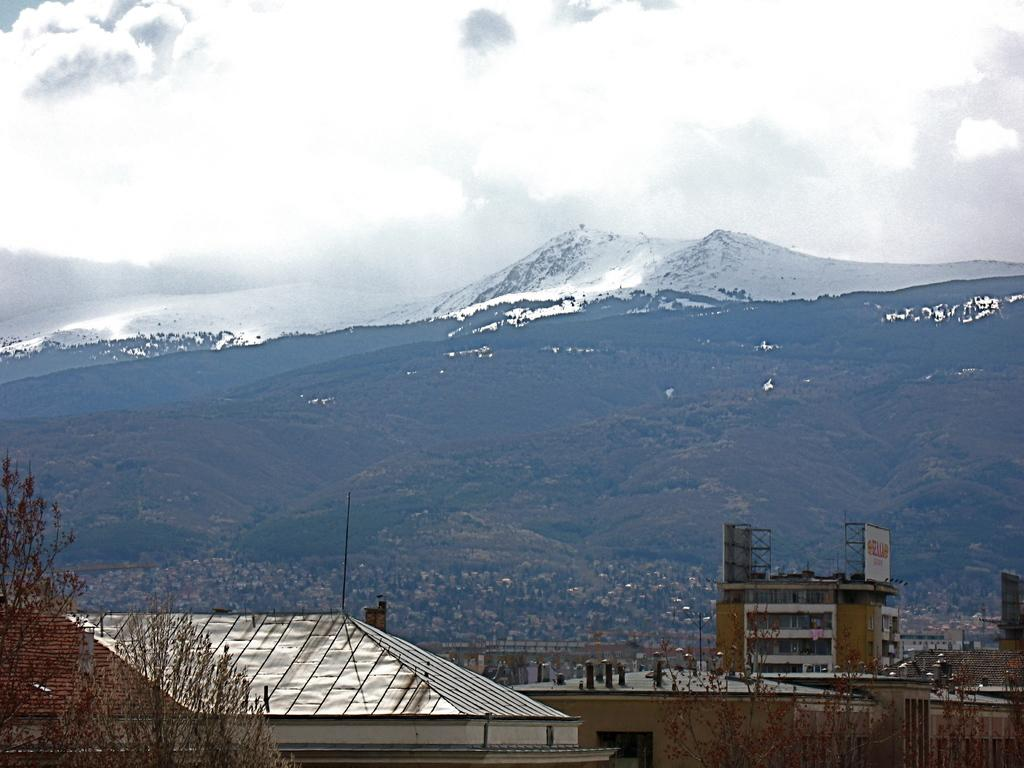What type of structures can be seen in the image? There are buildings in the image. What natural elements are present in the image? There are trees and mountains in the image. What part of the natural environment is visible in the image? The sky is visible in the background of the image. Can you tell me which eye the hospital is located near in the image? There is no hospital present in the image, so it is not possible to determine which eye it might be located near. 